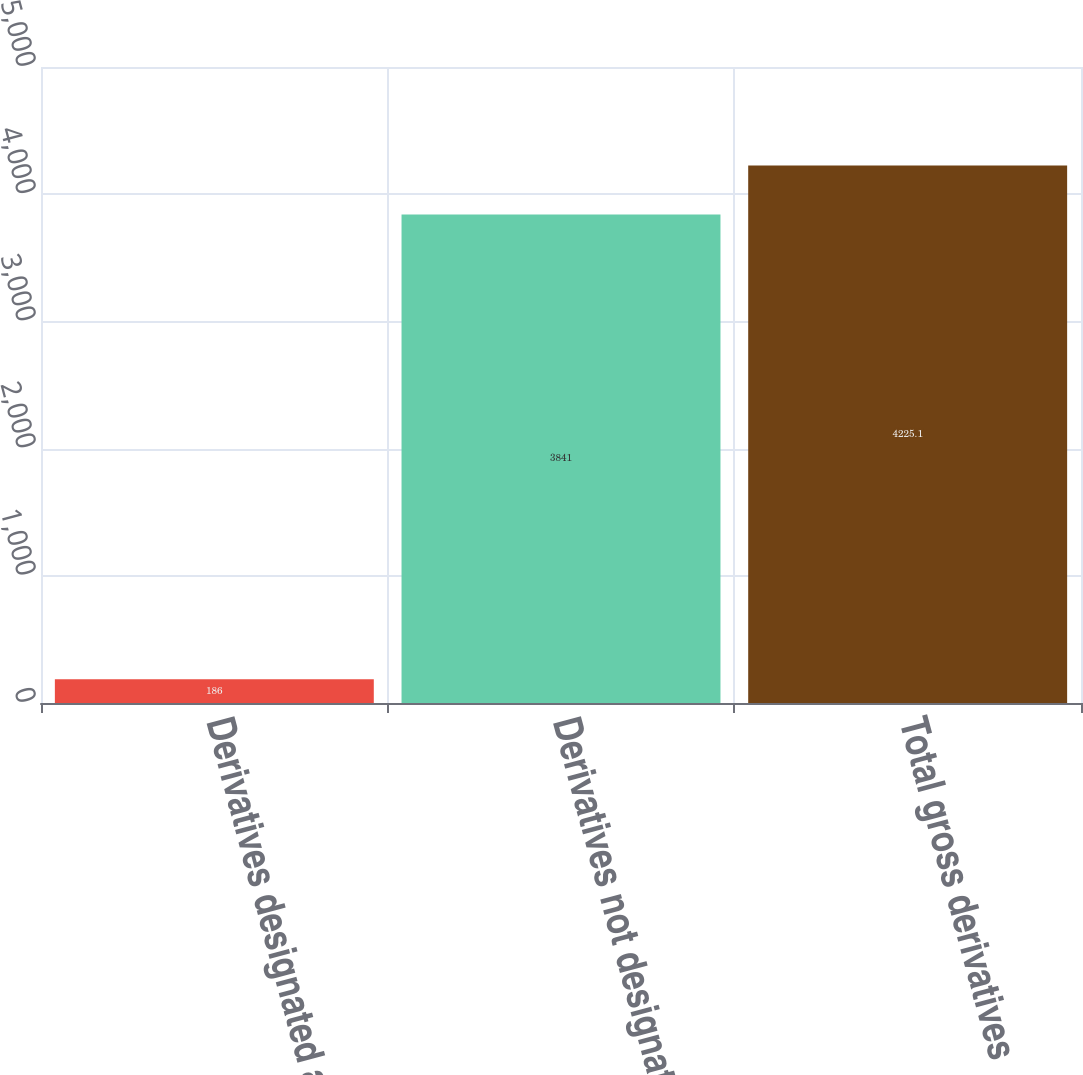Convert chart. <chart><loc_0><loc_0><loc_500><loc_500><bar_chart><fcel>Derivatives designated as<fcel>Derivatives not designated as<fcel>Total gross derivatives<nl><fcel>186<fcel>3841<fcel>4225.1<nl></chart> 